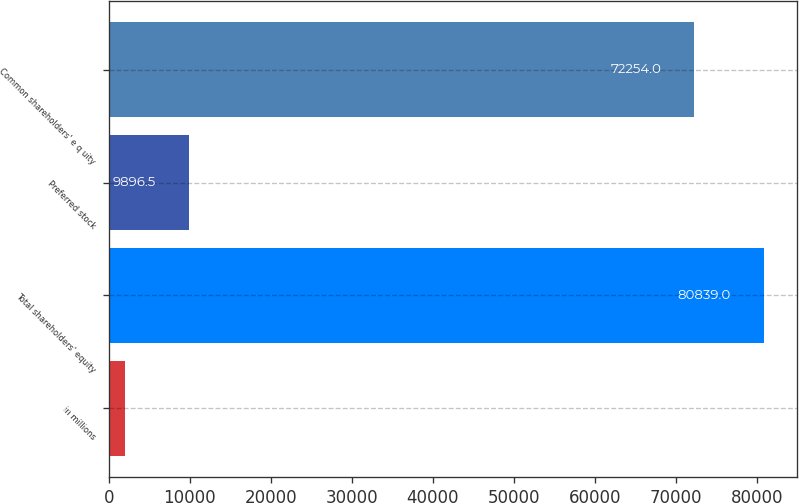Convert chart. <chart><loc_0><loc_0><loc_500><loc_500><bar_chart><fcel>in millions<fcel>Total shareholders' equity<fcel>Preferred stock<fcel>Common shareholders' e q uity<nl><fcel>2014<fcel>80839<fcel>9896.5<fcel>72254<nl></chart> 